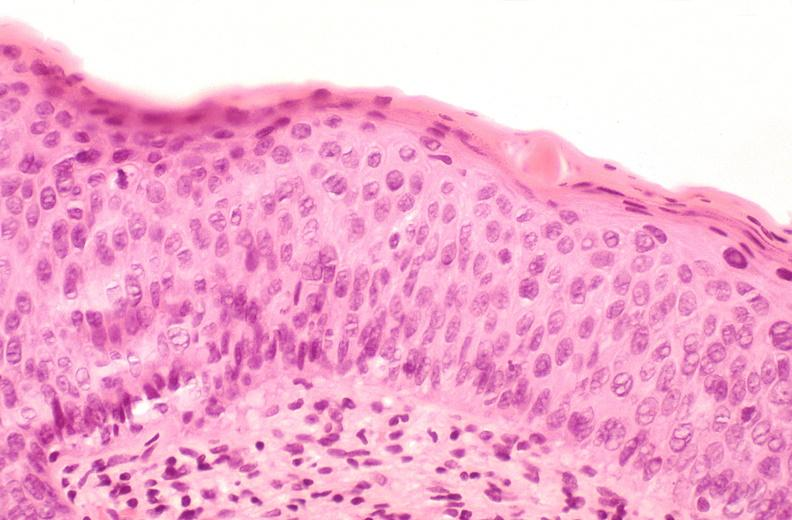s female reproductive present?
Answer the question using a single word or phrase. Yes 